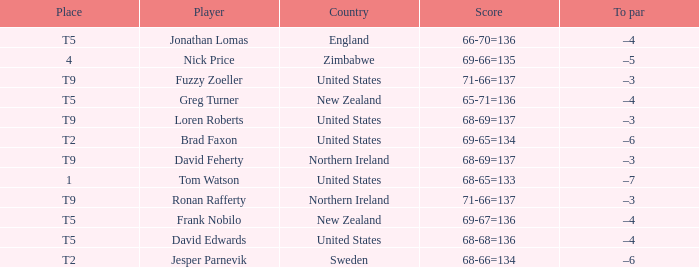Who is the golfer that golfs for Northern Ireland? David Feherty, Ronan Rafferty. 